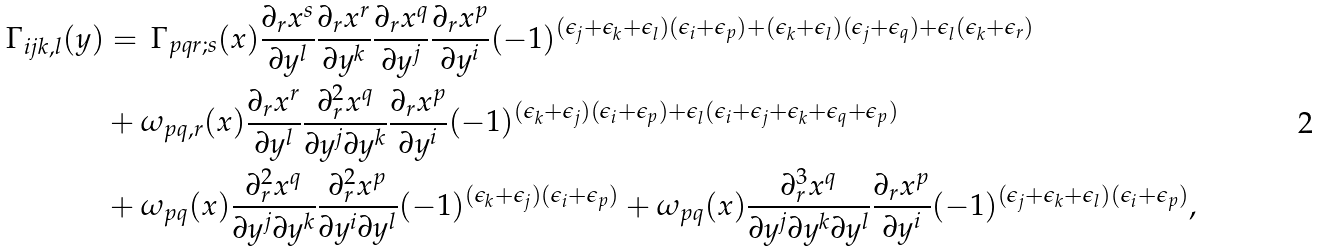<formula> <loc_0><loc_0><loc_500><loc_500>\Gamma _ { i j k , l } ( y ) & = \, \Gamma _ { p q r ; s } ( x ) \frac { \partial _ { r } x ^ { s } } { \partial y ^ { l } } \frac { \partial _ { r } x ^ { r } } { \partial y ^ { k } } \frac { \partial _ { r } x ^ { q } } { \partial y ^ { j } } \frac { \partial _ { r } x ^ { p } } { \partial y ^ { i } } ( - 1 ) ^ { ( \epsilon _ { j } + \epsilon _ { k } + \epsilon _ { l } ) ( \epsilon _ { i } + \epsilon _ { p } ) + ( \epsilon _ { k } + \epsilon _ { l } ) ( \epsilon _ { j } + \epsilon _ { q } ) + \epsilon _ { l } ( \epsilon _ { k } + \epsilon _ { r } ) } \\ & + \omega _ { p q , r } ( x ) \frac { \partial _ { r } x ^ { r } } { \partial y ^ { l } } \frac { \partial ^ { 2 } _ { r } x ^ { q } } { \partial y ^ { j } \partial y ^ { k } } \frac { \partial _ { r } x ^ { p } } { \partial y ^ { i } } ( - 1 ) ^ { ( \epsilon _ { k } + \epsilon _ { j } ) ( \epsilon _ { i } + \epsilon _ { p } ) + \epsilon _ { l } ( \epsilon _ { i } + \epsilon _ { j } + \epsilon _ { k } + \epsilon _ { q } + \epsilon _ { p } ) } \\ & + \omega _ { p q } ( x ) \frac { \partial ^ { 2 } _ { r } x ^ { q } } { \partial y ^ { j } \partial y ^ { k } } \frac { \partial ^ { 2 } _ { r } x ^ { p } } { \partial y ^ { i } \partial y ^ { l } } ( - 1 ) ^ { ( \epsilon _ { k } + \epsilon _ { j } ) ( \epsilon _ { i } + \epsilon _ { p } ) } + \omega _ { p q } ( x ) \frac { \partial ^ { 3 } _ { r } x ^ { q } } { \partial y ^ { j } \partial y ^ { k } \partial y ^ { l } } \frac { \partial _ { r } x ^ { p } } { \partial y ^ { i } } ( - 1 ) ^ { ( \epsilon _ { j } + \epsilon _ { k } + \epsilon _ { l } ) ( \epsilon _ { i } + \epsilon _ { p } ) } ,</formula> 